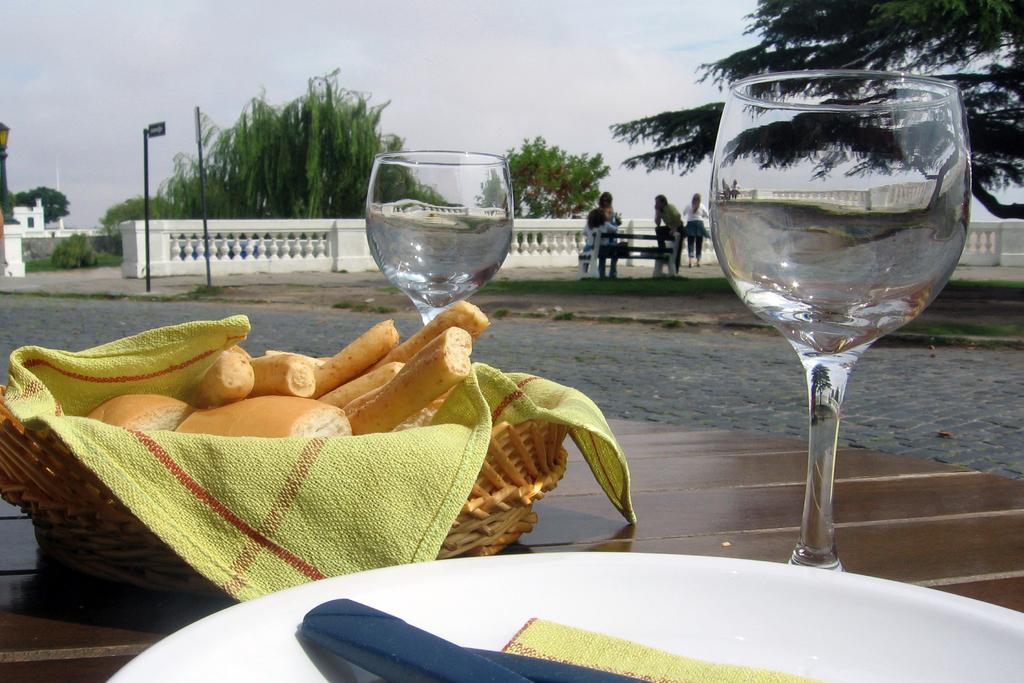Could you give a brief overview of what you see in this image? In this image I can see the table. On the table I can see the plate, bowl and the glasses. In the bowl I can see the cloth and the food. In the background I can see few people standing beside the railing. In the background there are trees and the white sky. 